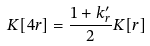Convert formula to latex. <formula><loc_0><loc_0><loc_500><loc_500>K [ 4 r ] = \frac { 1 + k ^ { \prime } _ { r } } { 2 } K [ r ]</formula> 